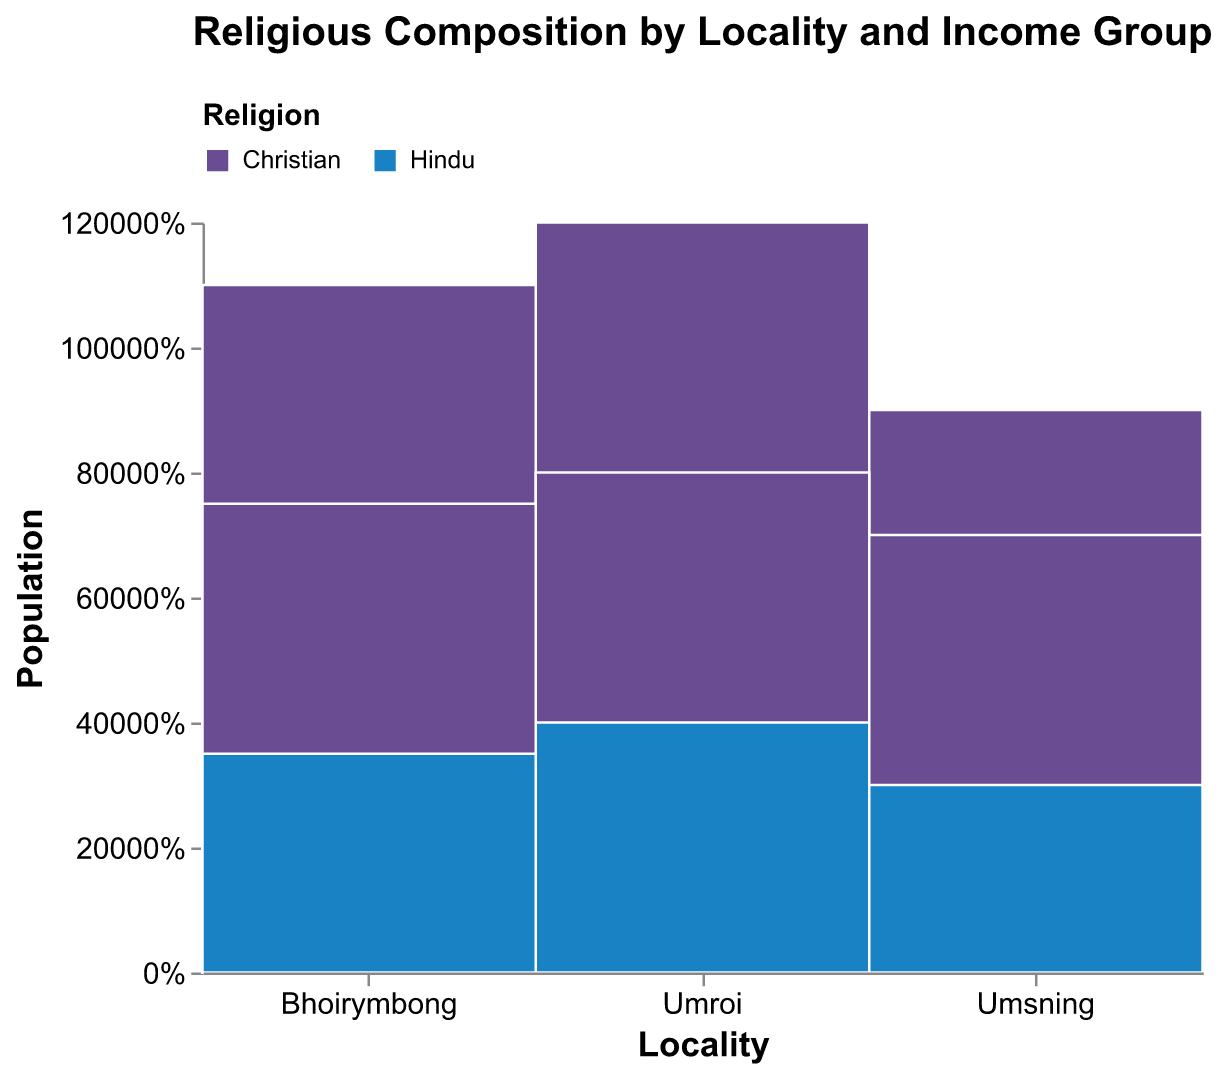What is the title of the figure? The title of the figure is located at the top and is meant to describe what the figure represents.
Answer: Religious Composition by Locality and Income Group Which locality has the highest population of Christians in the low-income group? You need to look at the section corresponding to the "Low" income group for Christians in each locality and compare their sizes.
Answer: Umroi Which religion has a larger population in Umsning's middle-income group? Look at the part of the plot corresponding to the "Middle" income group in Umsning and compare the sizes of the sections for Christians and Hindus.
Answer: Christian What percentage of Bhoirymbong's population in the high-income group is Hindu? Find the section of the plot corresponding to Bhoirymbong, high-income, and Hindu; calculate the height of this section relative to the total height of Bhoirymbong's high-income sections.
Answer: 33.3% How does the population of Hindus in Umroi compare with that in Umsning for the low-income group? Compare the size of the "Low" income group sections for Hindus in both Umroi and Umsning.
Answer: Larger in Umroi Which income group has the highest population for Christians in Bhoirymbong? Identify the sections of Christians in Bhoirymbong and compare the sizes among "Low", "Middle", and "High" income groups.
Answer: Low How does the total population of Christians in Umroi compare to Christians in Umsning? Add up all three income groups for Christians in both Umroi and Umsning and compare the totals.
Answer: Higher in Umroi What is the total population of Hindus in the middle-income group across all localities? Add the populations of Hindus in the middle-income group for Umroi, Umsning, and Bhoirymbong together.
Answer: 1050 In which locality do Hindus make up a higher percentage of the low-income group compared to Christians? For each locality, compare the percentage sizes of the "Low" income group sections for Hindus and Christians.
Answer: Umsning Which locality has the smallest population in the high-income group, regardless of religion? Compare the total sections of the high-income group across all localities.
Answer: Umsning 